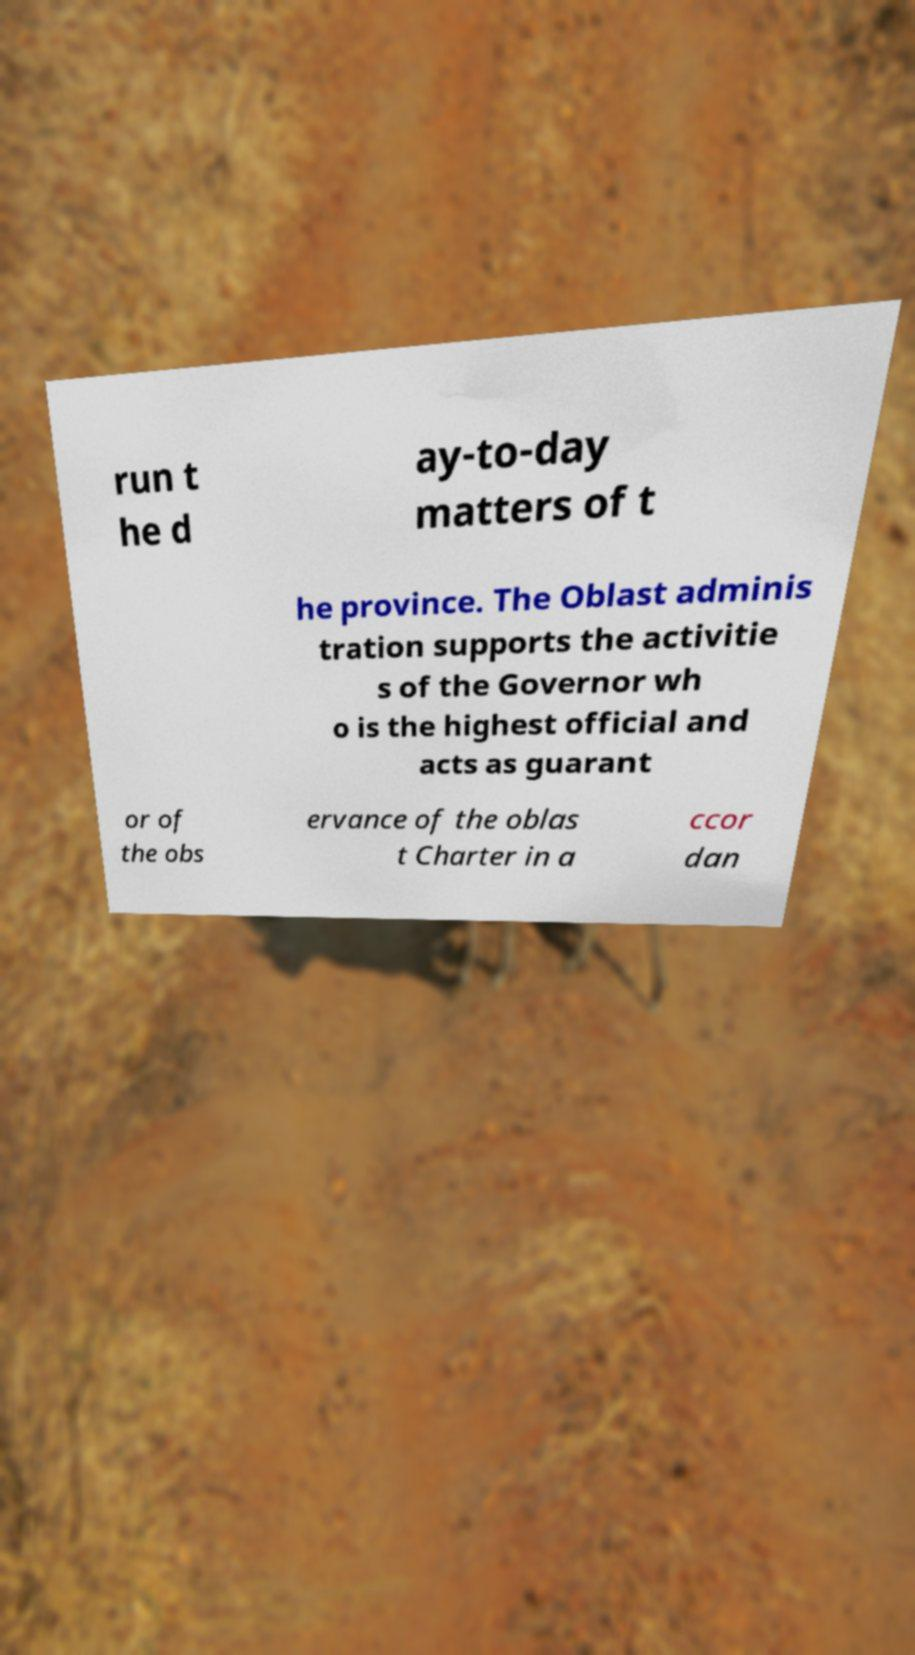There's text embedded in this image that I need extracted. Can you transcribe it verbatim? run t he d ay-to-day matters of t he province. The Oblast adminis tration supports the activitie s of the Governor wh o is the highest official and acts as guarant or of the obs ervance of the oblas t Charter in a ccor dan 